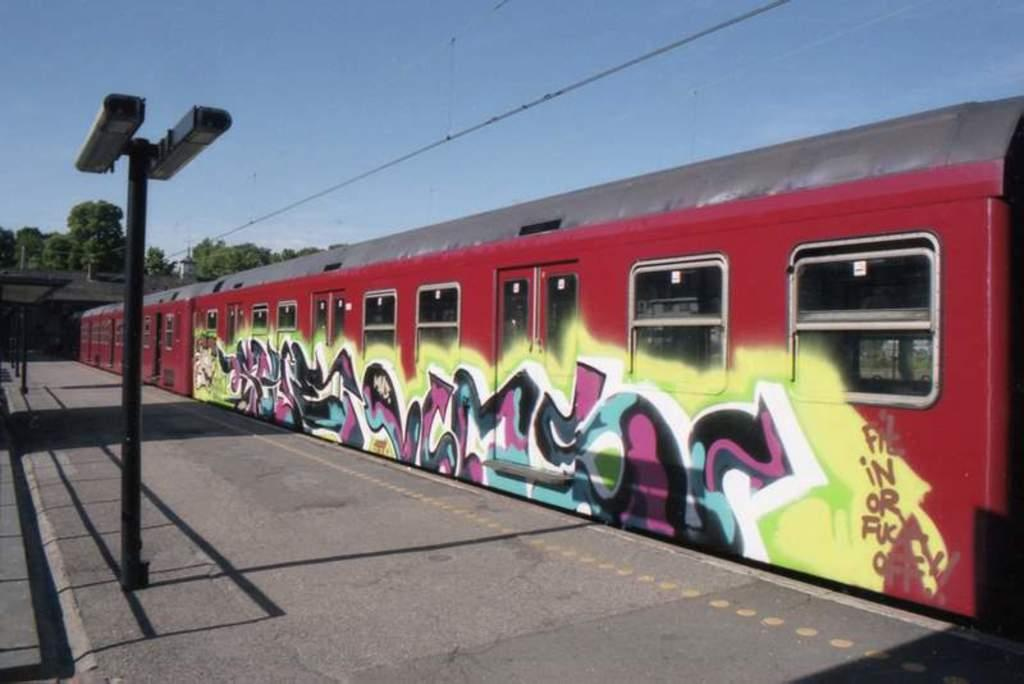What is the main subject of the image? The main subject of the image is a train. What can be seen on the path in the image? There are poles on the path in the image. What is present above the poles in the image? There are wires on top in the image. What is the color of the sky in the image? The sky is blue in color in the image. How many kittens are playing with the visitor in the image? There are no kittens or visitors present in the image; it features a train, poles, wires, and a blue sky. 